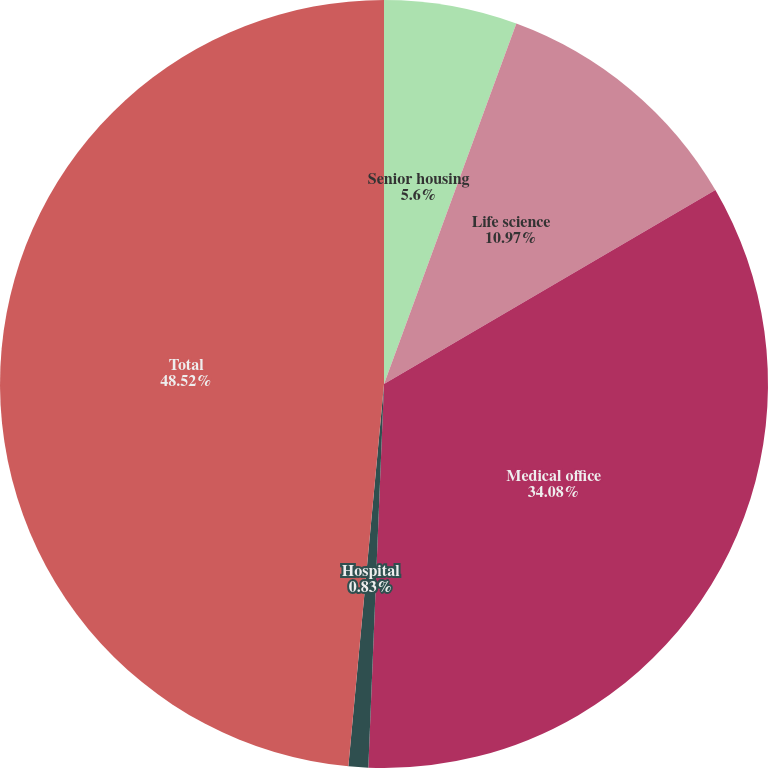Convert chart. <chart><loc_0><loc_0><loc_500><loc_500><pie_chart><fcel>Senior housing<fcel>Life science<fcel>Medical office<fcel>Hospital<fcel>Total<nl><fcel>5.6%<fcel>10.97%<fcel>34.08%<fcel>0.83%<fcel>48.52%<nl></chart> 